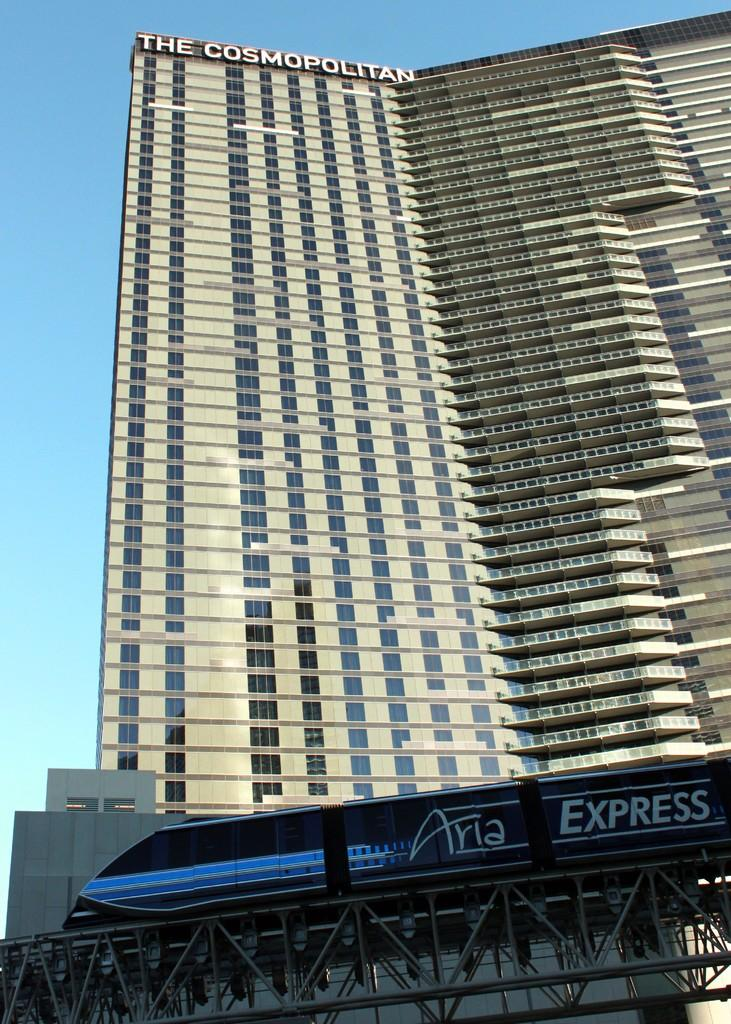<image>
Write a terse but informative summary of the picture. An Aria express train passes the Cosmopolitan building. 